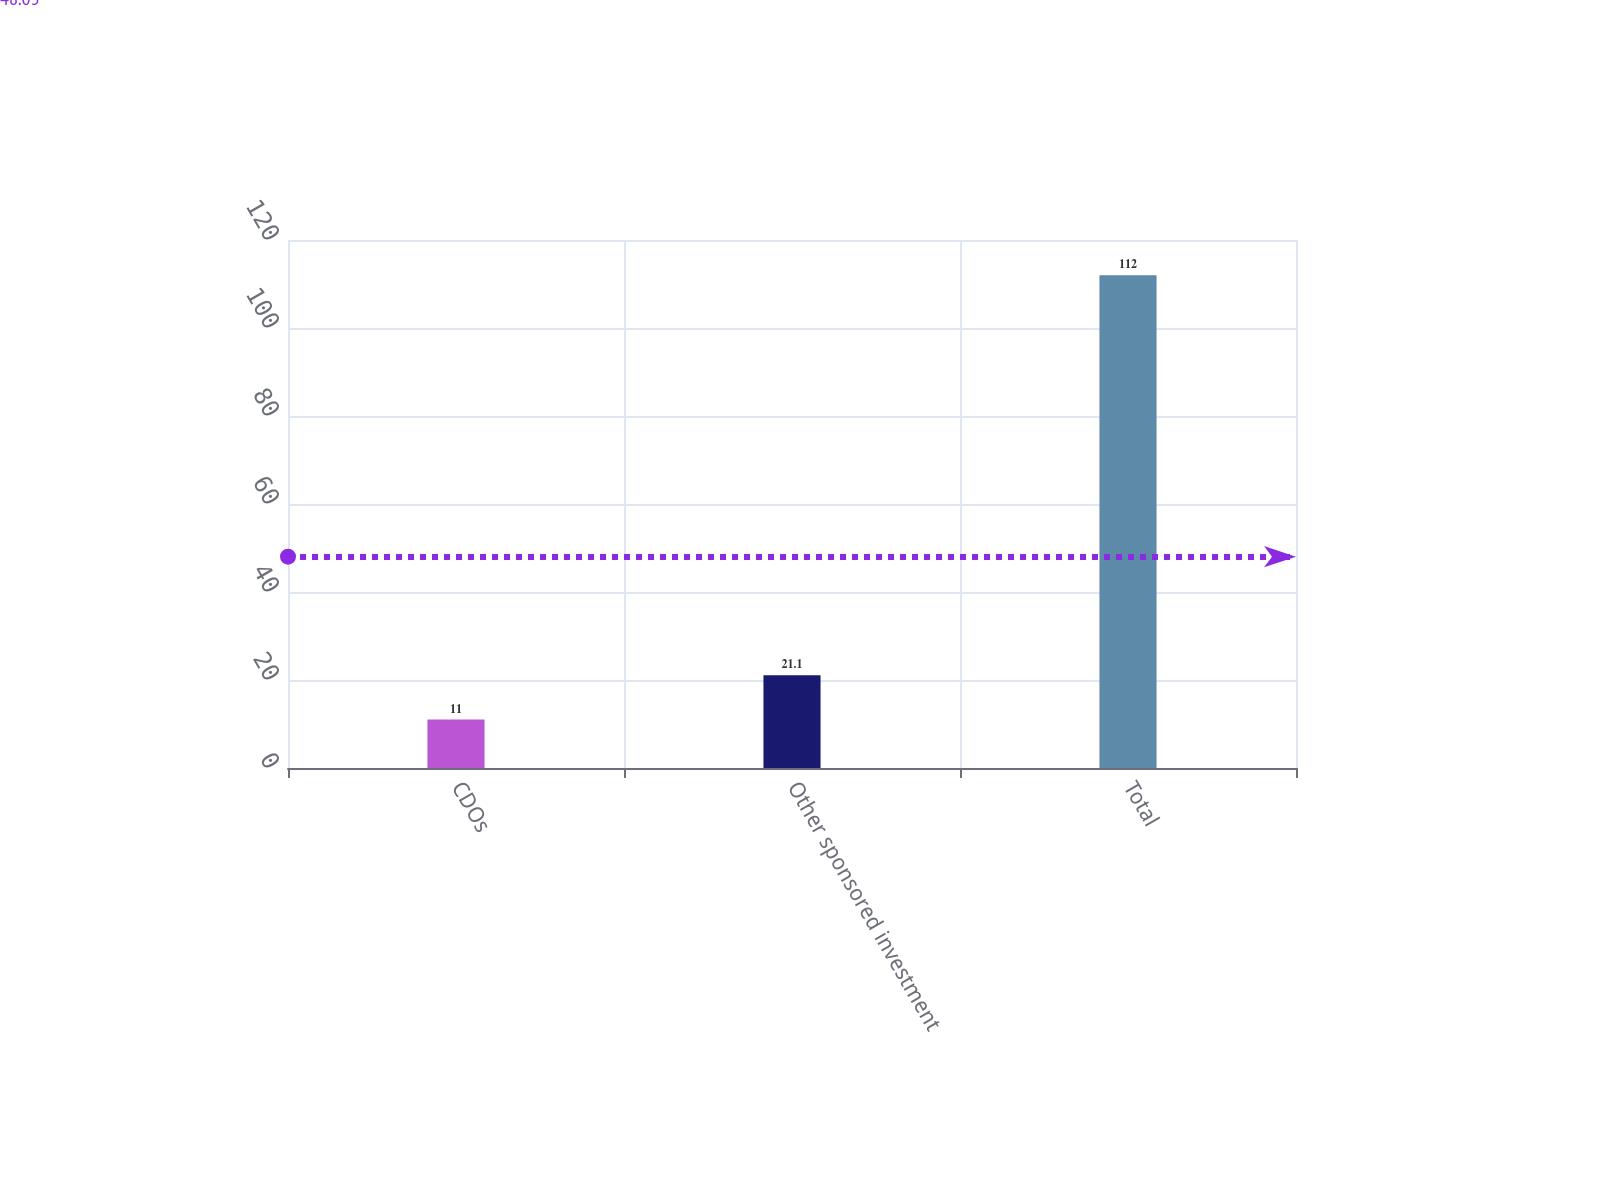Convert chart to OTSL. <chart><loc_0><loc_0><loc_500><loc_500><bar_chart><fcel>CDOs<fcel>Other sponsored investment<fcel>Total<nl><fcel>11<fcel>21.1<fcel>112<nl></chart> 